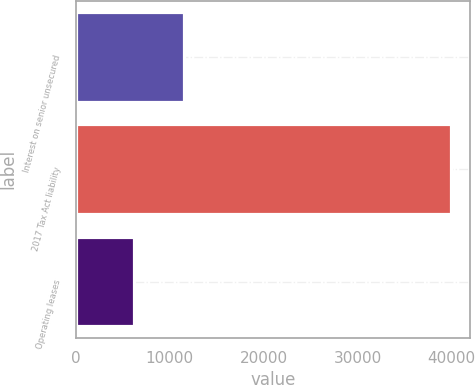<chart> <loc_0><loc_0><loc_500><loc_500><bar_chart><fcel>Interest on senior unsecured<fcel>2017 Tax Act liability<fcel>Operating leases<nl><fcel>11467<fcel>40000<fcel>6220<nl></chart> 